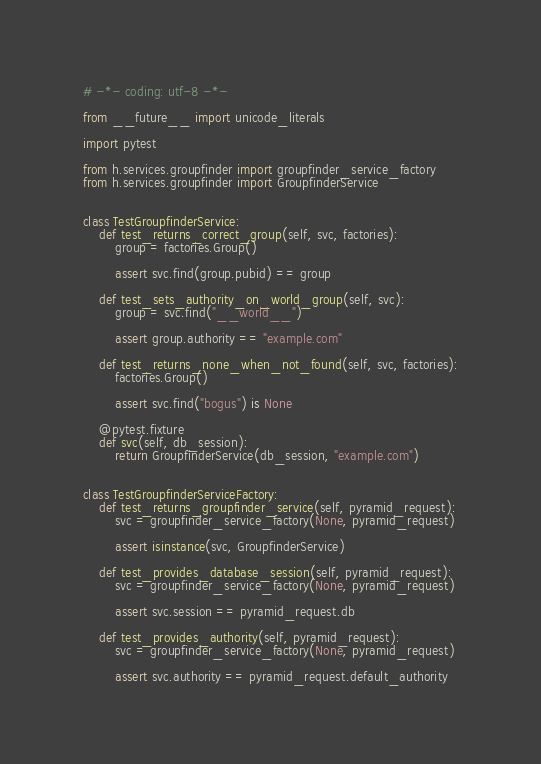Convert code to text. <code><loc_0><loc_0><loc_500><loc_500><_Python_># -*- coding: utf-8 -*-

from __future__ import unicode_literals

import pytest

from h.services.groupfinder import groupfinder_service_factory
from h.services.groupfinder import GroupfinderService


class TestGroupfinderService:
    def test_returns_correct_group(self, svc, factories):
        group = factories.Group()

        assert svc.find(group.pubid) == group

    def test_sets_authority_on_world_group(self, svc):
        group = svc.find("__world__")

        assert group.authority == "example.com"

    def test_returns_none_when_not_found(self, svc, factories):
        factories.Group()

        assert svc.find("bogus") is None

    @pytest.fixture
    def svc(self, db_session):
        return GroupfinderService(db_session, "example.com")


class TestGroupfinderServiceFactory:
    def test_returns_groupfinder_service(self, pyramid_request):
        svc = groupfinder_service_factory(None, pyramid_request)

        assert isinstance(svc, GroupfinderService)

    def test_provides_database_session(self, pyramid_request):
        svc = groupfinder_service_factory(None, pyramid_request)

        assert svc.session == pyramid_request.db

    def test_provides_authority(self, pyramid_request):
        svc = groupfinder_service_factory(None, pyramid_request)

        assert svc.authority == pyramid_request.default_authority
</code> 